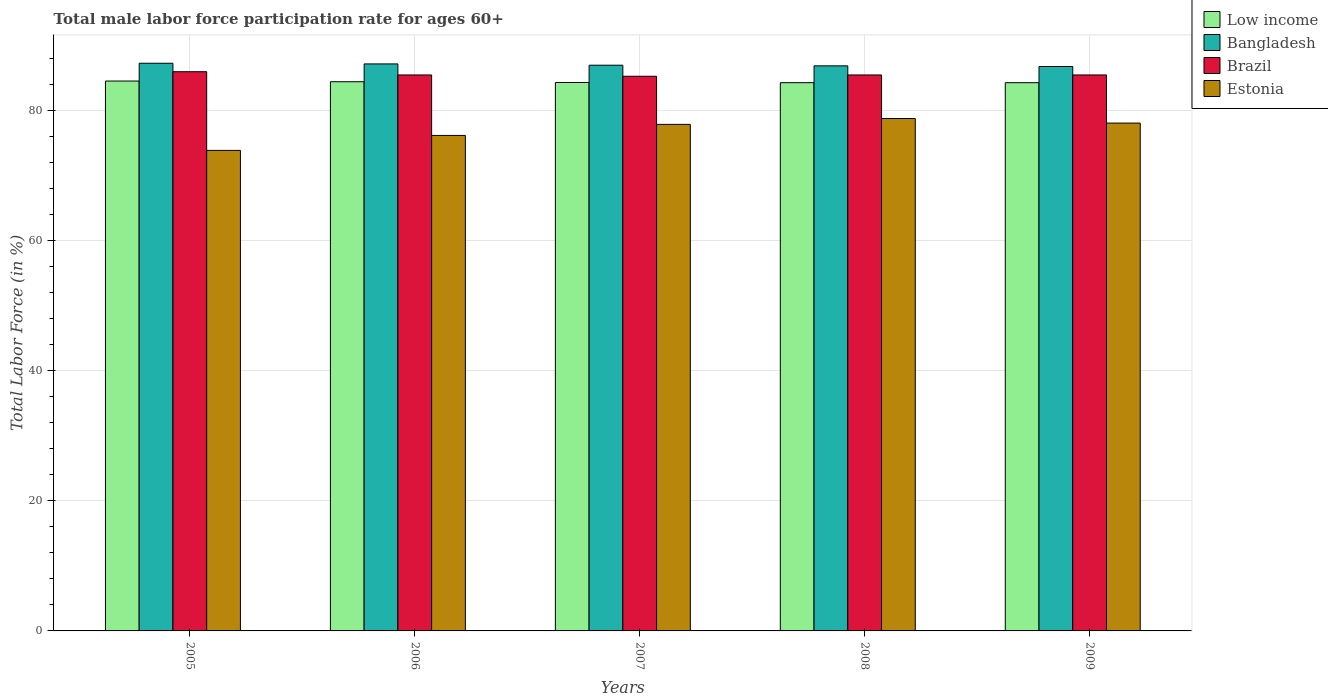How many different coloured bars are there?
Offer a terse response. 4. Are the number of bars per tick equal to the number of legend labels?
Your answer should be very brief. Yes. Are the number of bars on each tick of the X-axis equal?
Provide a short and direct response. Yes. How many bars are there on the 5th tick from the left?
Offer a terse response. 4. What is the label of the 1st group of bars from the left?
Your response must be concise. 2005. What is the male labor force participation rate in Low income in 2006?
Ensure brevity in your answer.  84.46. Across all years, what is the maximum male labor force participation rate in Brazil?
Make the answer very short. 86. Across all years, what is the minimum male labor force participation rate in Brazil?
Offer a terse response. 85.3. In which year was the male labor force participation rate in Estonia minimum?
Offer a terse response. 2005. What is the total male labor force participation rate in Brazil in the graph?
Your answer should be very brief. 427.8. What is the difference between the male labor force participation rate in Bangladesh in 2007 and that in 2009?
Make the answer very short. 0.2. What is the difference between the male labor force participation rate in Bangladesh in 2005 and the male labor force participation rate in Estonia in 2006?
Your answer should be compact. 11.1. What is the average male labor force participation rate in Brazil per year?
Offer a terse response. 85.56. In the year 2007, what is the difference between the male labor force participation rate in Brazil and male labor force participation rate in Estonia?
Your answer should be compact. 7.4. What is the ratio of the male labor force participation rate in Brazil in 2005 to that in 2007?
Offer a very short reply. 1.01. What is the difference between the highest and the second highest male labor force participation rate in Bangladesh?
Keep it short and to the point. 0.1. What is the difference between the highest and the lowest male labor force participation rate in Low income?
Keep it short and to the point. 0.25. Is the sum of the male labor force participation rate in Low income in 2005 and 2006 greater than the maximum male labor force participation rate in Bangladesh across all years?
Offer a terse response. Yes. Is it the case that in every year, the sum of the male labor force participation rate in Low income and male labor force participation rate in Estonia is greater than the sum of male labor force participation rate in Brazil and male labor force participation rate in Bangladesh?
Make the answer very short. Yes. What does the 1st bar from the right in 2009 represents?
Provide a short and direct response. Estonia. How many years are there in the graph?
Provide a succinct answer. 5. Does the graph contain grids?
Ensure brevity in your answer.  Yes. Where does the legend appear in the graph?
Provide a succinct answer. Top right. How many legend labels are there?
Your response must be concise. 4. What is the title of the graph?
Make the answer very short. Total male labor force participation rate for ages 60+. What is the Total Labor Force (in %) of Low income in 2005?
Offer a very short reply. 84.57. What is the Total Labor Force (in %) of Bangladesh in 2005?
Offer a very short reply. 87.3. What is the Total Labor Force (in %) in Brazil in 2005?
Your answer should be very brief. 86. What is the Total Labor Force (in %) of Estonia in 2005?
Keep it short and to the point. 73.9. What is the Total Labor Force (in %) of Low income in 2006?
Ensure brevity in your answer.  84.46. What is the Total Labor Force (in %) of Bangladesh in 2006?
Make the answer very short. 87.2. What is the Total Labor Force (in %) of Brazil in 2006?
Make the answer very short. 85.5. What is the Total Labor Force (in %) of Estonia in 2006?
Provide a succinct answer. 76.2. What is the Total Labor Force (in %) of Low income in 2007?
Provide a short and direct response. 84.34. What is the Total Labor Force (in %) of Bangladesh in 2007?
Keep it short and to the point. 87. What is the Total Labor Force (in %) of Brazil in 2007?
Ensure brevity in your answer.  85.3. What is the Total Labor Force (in %) of Estonia in 2007?
Provide a short and direct response. 77.9. What is the Total Labor Force (in %) in Low income in 2008?
Provide a short and direct response. 84.31. What is the Total Labor Force (in %) of Bangladesh in 2008?
Make the answer very short. 86.9. What is the Total Labor Force (in %) of Brazil in 2008?
Keep it short and to the point. 85.5. What is the Total Labor Force (in %) of Estonia in 2008?
Give a very brief answer. 78.8. What is the Total Labor Force (in %) in Low income in 2009?
Offer a terse response. 84.31. What is the Total Labor Force (in %) of Bangladesh in 2009?
Your answer should be very brief. 86.8. What is the Total Labor Force (in %) in Brazil in 2009?
Provide a short and direct response. 85.5. What is the Total Labor Force (in %) in Estonia in 2009?
Keep it short and to the point. 78.1. Across all years, what is the maximum Total Labor Force (in %) in Low income?
Ensure brevity in your answer.  84.57. Across all years, what is the maximum Total Labor Force (in %) of Bangladesh?
Ensure brevity in your answer.  87.3. Across all years, what is the maximum Total Labor Force (in %) in Estonia?
Offer a terse response. 78.8. Across all years, what is the minimum Total Labor Force (in %) in Low income?
Provide a succinct answer. 84.31. Across all years, what is the minimum Total Labor Force (in %) in Bangladesh?
Ensure brevity in your answer.  86.8. Across all years, what is the minimum Total Labor Force (in %) in Brazil?
Make the answer very short. 85.3. Across all years, what is the minimum Total Labor Force (in %) in Estonia?
Offer a very short reply. 73.9. What is the total Total Labor Force (in %) of Low income in the graph?
Your answer should be very brief. 421.99. What is the total Total Labor Force (in %) of Bangladesh in the graph?
Offer a very short reply. 435.2. What is the total Total Labor Force (in %) in Brazil in the graph?
Your response must be concise. 427.8. What is the total Total Labor Force (in %) in Estonia in the graph?
Keep it short and to the point. 384.9. What is the difference between the Total Labor Force (in %) of Low income in 2005 and that in 2006?
Your answer should be compact. 0.11. What is the difference between the Total Labor Force (in %) in Brazil in 2005 and that in 2006?
Offer a terse response. 0.5. What is the difference between the Total Labor Force (in %) of Low income in 2005 and that in 2007?
Ensure brevity in your answer.  0.22. What is the difference between the Total Labor Force (in %) in Bangladesh in 2005 and that in 2007?
Ensure brevity in your answer.  0.3. What is the difference between the Total Labor Force (in %) in Low income in 2005 and that in 2008?
Provide a succinct answer. 0.25. What is the difference between the Total Labor Force (in %) in Brazil in 2005 and that in 2008?
Offer a very short reply. 0.5. What is the difference between the Total Labor Force (in %) in Estonia in 2005 and that in 2008?
Provide a succinct answer. -4.9. What is the difference between the Total Labor Force (in %) of Low income in 2005 and that in 2009?
Offer a very short reply. 0.25. What is the difference between the Total Labor Force (in %) of Bangladesh in 2005 and that in 2009?
Make the answer very short. 0.5. What is the difference between the Total Labor Force (in %) in Estonia in 2005 and that in 2009?
Keep it short and to the point. -4.2. What is the difference between the Total Labor Force (in %) of Low income in 2006 and that in 2007?
Your response must be concise. 0.12. What is the difference between the Total Labor Force (in %) of Bangladesh in 2006 and that in 2007?
Keep it short and to the point. 0.2. What is the difference between the Total Labor Force (in %) of Low income in 2006 and that in 2008?
Keep it short and to the point. 0.15. What is the difference between the Total Labor Force (in %) of Estonia in 2006 and that in 2008?
Your response must be concise. -2.6. What is the difference between the Total Labor Force (in %) in Low income in 2006 and that in 2009?
Your answer should be very brief. 0.15. What is the difference between the Total Labor Force (in %) of Bangladesh in 2006 and that in 2009?
Ensure brevity in your answer.  0.4. What is the difference between the Total Labor Force (in %) of Brazil in 2006 and that in 2009?
Ensure brevity in your answer.  0. What is the difference between the Total Labor Force (in %) in Estonia in 2006 and that in 2009?
Keep it short and to the point. -1.9. What is the difference between the Total Labor Force (in %) in Low income in 2007 and that in 2008?
Your answer should be compact. 0.03. What is the difference between the Total Labor Force (in %) in Bangladesh in 2007 and that in 2008?
Keep it short and to the point. 0.1. What is the difference between the Total Labor Force (in %) in Estonia in 2007 and that in 2008?
Give a very brief answer. -0.9. What is the difference between the Total Labor Force (in %) in Low income in 2007 and that in 2009?
Your answer should be very brief. 0.03. What is the difference between the Total Labor Force (in %) in Bangladesh in 2007 and that in 2009?
Ensure brevity in your answer.  0.2. What is the difference between the Total Labor Force (in %) of Low income in 2008 and that in 2009?
Offer a terse response. 0. What is the difference between the Total Labor Force (in %) in Bangladesh in 2008 and that in 2009?
Your answer should be very brief. 0.1. What is the difference between the Total Labor Force (in %) of Brazil in 2008 and that in 2009?
Ensure brevity in your answer.  0. What is the difference between the Total Labor Force (in %) of Low income in 2005 and the Total Labor Force (in %) of Bangladesh in 2006?
Provide a succinct answer. -2.63. What is the difference between the Total Labor Force (in %) of Low income in 2005 and the Total Labor Force (in %) of Brazil in 2006?
Offer a terse response. -0.93. What is the difference between the Total Labor Force (in %) in Low income in 2005 and the Total Labor Force (in %) in Estonia in 2006?
Offer a terse response. 8.37. What is the difference between the Total Labor Force (in %) of Bangladesh in 2005 and the Total Labor Force (in %) of Brazil in 2006?
Provide a short and direct response. 1.8. What is the difference between the Total Labor Force (in %) of Bangladesh in 2005 and the Total Labor Force (in %) of Estonia in 2006?
Your answer should be compact. 11.1. What is the difference between the Total Labor Force (in %) in Brazil in 2005 and the Total Labor Force (in %) in Estonia in 2006?
Keep it short and to the point. 9.8. What is the difference between the Total Labor Force (in %) of Low income in 2005 and the Total Labor Force (in %) of Bangladesh in 2007?
Make the answer very short. -2.43. What is the difference between the Total Labor Force (in %) of Low income in 2005 and the Total Labor Force (in %) of Brazil in 2007?
Your answer should be very brief. -0.73. What is the difference between the Total Labor Force (in %) in Low income in 2005 and the Total Labor Force (in %) in Estonia in 2007?
Offer a terse response. 6.67. What is the difference between the Total Labor Force (in %) of Bangladesh in 2005 and the Total Labor Force (in %) of Estonia in 2007?
Offer a very short reply. 9.4. What is the difference between the Total Labor Force (in %) of Low income in 2005 and the Total Labor Force (in %) of Bangladesh in 2008?
Provide a succinct answer. -2.33. What is the difference between the Total Labor Force (in %) of Low income in 2005 and the Total Labor Force (in %) of Brazil in 2008?
Your response must be concise. -0.93. What is the difference between the Total Labor Force (in %) of Low income in 2005 and the Total Labor Force (in %) of Estonia in 2008?
Offer a terse response. 5.77. What is the difference between the Total Labor Force (in %) of Brazil in 2005 and the Total Labor Force (in %) of Estonia in 2008?
Your answer should be very brief. 7.2. What is the difference between the Total Labor Force (in %) of Low income in 2005 and the Total Labor Force (in %) of Bangladesh in 2009?
Your answer should be compact. -2.23. What is the difference between the Total Labor Force (in %) in Low income in 2005 and the Total Labor Force (in %) in Brazil in 2009?
Provide a succinct answer. -0.93. What is the difference between the Total Labor Force (in %) in Low income in 2005 and the Total Labor Force (in %) in Estonia in 2009?
Give a very brief answer. 6.47. What is the difference between the Total Labor Force (in %) in Bangladesh in 2005 and the Total Labor Force (in %) in Estonia in 2009?
Make the answer very short. 9.2. What is the difference between the Total Labor Force (in %) of Brazil in 2005 and the Total Labor Force (in %) of Estonia in 2009?
Offer a very short reply. 7.9. What is the difference between the Total Labor Force (in %) of Low income in 2006 and the Total Labor Force (in %) of Bangladesh in 2007?
Provide a short and direct response. -2.54. What is the difference between the Total Labor Force (in %) in Low income in 2006 and the Total Labor Force (in %) in Brazil in 2007?
Your response must be concise. -0.84. What is the difference between the Total Labor Force (in %) in Low income in 2006 and the Total Labor Force (in %) in Estonia in 2007?
Provide a short and direct response. 6.56. What is the difference between the Total Labor Force (in %) in Bangladesh in 2006 and the Total Labor Force (in %) in Brazil in 2007?
Provide a short and direct response. 1.9. What is the difference between the Total Labor Force (in %) of Bangladesh in 2006 and the Total Labor Force (in %) of Estonia in 2007?
Offer a very short reply. 9.3. What is the difference between the Total Labor Force (in %) of Low income in 2006 and the Total Labor Force (in %) of Bangladesh in 2008?
Provide a short and direct response. -2.44. What is the difference between the Total Labor Force (in %) in Low income in 2006 and the Total Labor Force (in %) in Brazil in 2008?
Provide a short and direct response. -1.04. What is the difference between the Total Labor Force (in %) in Low income in 2006 and the Total Labor Force (in %) in Estonia in 2008?
Your answer should be very brief. 5.66. What is the difference between the Total Labor Force (in %) in Bangladesh in 2006 and the Total Labor Force (in %) in Brazil in 2008?
Your response must be concise. 1.7. What is the difference between the Total Labor Force (in %) in Bangladesh in 2006 and the Total Labor Force (in %) in Estonia in 2008?
Ensure brevity in your answer.  8.4. What is the difference between the Total Labor Force (in %) in Low income in 2006 and the Total Labor Force (in %) in Bangladesh in 2009?
Offer a terse response. -2.34. What is the difference between the Total Labor Force (in %) in Low income in 2006 and the Total Labor Force (in %) in Brazil in 2009?
Make the answer very short. -1.04. What is the difference between the Total Labor Force (in %) of Low income in 2006 and the Total Labor Force (in %) of Estonia in 2009?
Provide a succinct answer. 6.36. What is the difference between the Total Labor Force (in %) in Bangladesh in 2006 and the Total Labor Force (in %) in Brazil in 2009?
Keep it short and to the point. 1.7. What is the difference between the Total Labor Force (in %) in Bangladesh in 2006 and the Total Labor Force (in %) in Estonia in 2009?
Keep it short and to the point. 9.1. What is the difference between the Total Labor Force (in %) in Low income in 2007 and the Total Labor Force (in %) in Bangladesh in 2008?
Your answer should be very brief. -2.56. What is the difference between the Total Labor Force (in %) of Low income in 2007 and the Total Labor Force (in %) of Brazil in 2008?
Give a very brief answer. -1.16. What is the difference between the Total Labor Force (in %) of Low income in 2007 and the Total Labor Force (in %) of Estonia in 2008?
Offer a very short reply. 5.54. What is the difference between the Total Labor Force (in %) in Bangladesh in 2007 and the Total Labor Force (in %) in Brazil in 2008?
Offer a very short reply. 1.5. What is the difference between the Total Labor Force (in %) in Bangladesh in 2007 and the Total Labor Force (in %) in Estonia in 2008?
Provide a short and direct response. 8.2. What is the difference between the Total Labor Force (in %) in Brazil in 2007 and the Total Labor Force (in %) in Estonia in 2008?
Give a very brief answer. 6.5. What is the difference between the Total Labor Force (in %) in Low income in 2007 and the Total Labor Force (in %) in Bangladesh in 2009?
Provide a short and direct response. -2.46. What is the difference between the Total Labor Force (in %) in Low income in 2007 and the Total Labor Force (in %) in Brazil in 2009?
Provide a succinct answer. -1.16. What is the difference between the Total Labor Force (in %) in Low income in 2007 and the Total Labor Force (in %) in Estonia in 2009?
Ensure brevity in your answer.  6.24. What is the difference between the Total Labor Force (in %) of Bangladesh in 2007 and the Total Labor Force (in %) of Brazil in 2009?
Your answer should be compact. 1.5. What is the difference between the Total Labor Force (in %) in Brazil in 2007 and the Total Labor Force (in %) in Estonia in 2009?
Provide a short and direct response. 7.2. What is the difference between the Total Labor Force (in %) in Low income in 2008 and the Total Labor Force (in %) in Bangladesh in 2009?
Your response must be concise. -2.49. What is the difference between the Total Labor Force (in %) in Low income in 2008 and the Total Labor Force (in %) in Brazil in 2009?
Your answer should be very brief. -1.19. What is the difference between the Total Labor Force (in %) of Low income in 2008 and the Total Labor Force (in %) of Estonia in 2009?
Offer a terse response. 6.21. What is the average Total Labor Force (in %) in Low income per year?
Offer a very short reply. 84.4. What is the average Total Labor Force (in %) of Bangladesh per year?
Give a very brief answer. 87.04. What is the average Total Labor Force (in %) of Brazil per year?
Offer a terse response. 85.56. What is the average Total Labor Force (in %) in Estonia per year?
Give a very brief answer. 76.98. In the year 2005, what is the difference between the Total Labor Force (in %) of Low income and Total Labor Force (in %) of Bangladesh?
Your answer should be compact. -2.73. In the year 2005, what is the difference between the Total Labor Force (in %) of Low income and Total Labor Force (in %) of Brazil?
Offer a terse response. -1.43. In the year 2005, what is the difference between the Total Labor Force (in %) in Low income and Total Labor Force (in %) in Estonia?
Make the answer very short. 10.67. In the year 2005, what is the difference between the Total Labor Force (in %) in Bangladesh and Total Labor Force (in %) in Brazil?
Make the answer very short. 1.3. In the year 2005, what is the difference between the Total Labor Force (in %) of Bangladesh and Total Labor Force (in %) of Estonia?
Offer a very short reply. 13.4. In the year 2005, what is the difference between the Total Labor Force (in %) in Brazil and Total Labor Force (in %) in Estonia?
Ensure brevity in your answer.  12.1. In the year 2006, what is the difference between the Total Labor Force (in %) in Low income and Total Labor Force (in %) in Bangladesh?
Keep it short and to the point. -2.74. In the year 2006, what is the difference between the Total Labor Force (in %) of Low income and Total Labor Force (in %) of Brazil?
Give a very brief answer. -1.04. In the year 2006, what is the difference between the Total Labor Force (in %) in Low income and Total Labor Force (in %) in Estonia?
Keep it short and to the point. 8.26. In the year 2007, what is the difference between the Total Labor Force (in %) of Low income and Total Labor Force (in %) of Bangladesh?
Ensure brevity in your answer.  -2.66. In the year 2007, what is the difference between the Total Labor Force (in %) of Low income and Total Labor Force (in %) of Brazil?
Provide a succinct answer. -0.96. In the year 2007, what is the difference between the Total Labor Force (in %) of Low income and Total Labor Force (in %) of Estonia?
Your response must be concise. 6.44. In the year 2008, what is the difference between the Total Labor Force (in %) of Low income and Total Labor Force (in %) of Bangladesh?
Keep it short and to the point. -2.59. In the year 2008, what is the difference between the Total Labor Force (in %) of Low income and Total Labor Force (in %) of Brazil?
Ensure brevity in your answer.  -1.19. In the year 2008, what is the difference between the Total Labor Force (in %) in Low income and Total Labor Force (in %) in Estonia?
Keep it short and to the point. 5.51. In the year 2008, what is the difference between the Total Labor Force (in %) of Bangladesh and Total Labor Force (in %) of Brazil?
Keep it short and to the point. 1.4. In the year 2008, what is the difference between the Total Labor Force (in %) of Bangladesh and Total Labor Force (in %) of Estonia?
Ensure brevity in your answer.  8.1. In the year 2008, what is the difference between the Total Labor Force (in %) in Brazil and Total Labor Force (in %) in Estonia?
Offer a terse response. 6.7. In the year 2009, what is the difference between the Total Labor Force (in %) in Low income and Total Labor Force (in %) in Bangladesh?
Offer a terse response. -2.49. In the year 2009, what is the difference between the Total Labor Force (in %) of Low income and Total Labor Force (in %) of Brazil?
Give a very brief answer. -1.19. In the year 2009, what is the difference between the Total Labor Force (in %) in Low income and Total Labor Force (in %) in Estonia?
Your answer should be compact. 6.21. In the year 2009, what is the difference between the Total Labor Force (in %) of Bangladesh and Total Labor Force (in %) of Brazil?
Make the answer very short. 1.3. What is the ratio of the Total Labor Force (in %) in Bangladesh in 2005 to that in 2006?
Offer a terse response. 1. What is the ratio of the Total Labor Force (in %) in Brazil in 2005 to that in 2006?
Keep it short and to the point. 1.01. What is the ratio of the Total Labor Force (in %) of Estonia in 2005 to that in 2006?
Provide a short and direct response. 0.97. What is the ratio of the Total Labor Force (in %) in Low income in 2005 to that in 2007?
Ensure brevity in your answer.  1. What is the ratio of the Total Labor Force (in %) of Brazil in 2005 to that in 2007?
Your answer should be compact. 1.01. What is the ratio of the Total Labor Force (in %) of Estonia in 2005 to that in 2007?
Give a very brief answer. 0.95. What is the ratio of the Total Labor Force (in %) in Bangladesh in 2005 to that in 2008?
Provide a succinct answer. 1. What is the ratio of the Total Labor Force (in %) of Brazil in 2005 to that in 2008?
Your answer should be very brief. 1.01. What is the ratio of the Total Labor Force (in %) in Estonia in 2005 to that in 2008?
Make the answer very short. 0.94. What is the ratio of the Total Labor Force (in %) of Bangladesh in 2005 to that in 2009?
Keep it short and to the point. 1.01. What is the ratio of the Total Labor Force (in %) of Brazil in 2005 to that in 2009?
Your answer should be very brief. 1.01. What is the ratio of the Total Labor Force (in %) in Estonia in 2005 to that in 2009?
Provide a succinct answer. 0.95. What is the ratio of the Total Labor Force (in %) in Low income in 2006 to that in 2007?
Offer a very short reply. 1. What is the ratio of the Total Labor Force (in %) in Bangladesh in 2006 to that in 2007?
Offer a terse response. 1. What is the ratio of the Total Labor Force (in %) of Brazil in 2006 to that in 2007?
Provide a succinct answer. 1. What is the ratio of the Total Labor Force (in %) of Estonia in 2006 to that in 2007?
Your answer should be very brief. 0.98. What is the ratio of the Total Labor Force (in %) of Brazil in 2006 to that in 2008?
Provide a short and direct response. 1. What is the ratio of the Total Labor Force (in %) in Estonia in 2006 to that in 2008?
Give a very brief answer. 0.97. What is the ratio of the Total Labor Force (in %) in Low income in 2006 to that in 2009?
Offer a terse response. 1. What is the ratio of the Total Labor Force (in %) of Estonia in 2006 to that in 2009?
Give a very brief answer. 0.98. What is the ratio of the Total Labor Force (in %) of Low income in 2007 to that in 2008?
Your answer should be compact. 1. What is the ratio of the Total Labor Force (in %) in Bangladesh in 2007 to that in 2008?
Make the answer very short. 1. What is the ratio of the Total Labor Force (in %) of Bangladesh in 2007 to that in 2009?
Give a very brief answer. 1. What is the ratio of the Total Labor Force (in %) in Estonia in 2007 to that in 2009?
Offer a terse response. 1. What is the ratio of the Total Labor Force (in %) of Low income in 2008 to that in 2009?
Ensure brevity in your answer.  1. What is the ratio of the Total Labor Force (in %) of Estonia in 2008 to that in 2009?
Your response must be concise. 1.01. What is the difference between the highest and the second highest Total Labor Force (in %) in Low income?
Provide a short and direct response. 0.11. What is the difference between the highest and the second highest Total Labor Force (in %) of Bangladesh?
Keep it short and to the point. 0.1. What is the difference between the highest and the second highest Total Labor Force (in %) of Brazil?
Make the answer very short. 0.5. What is the difference between the highest and the second highest Total Labor Force (in %) in Estonia?
Ensure brevity in your answer.  0.7. What is the difference between the highest and the lowest Total Labor Force (in %) of Low income?
Keep it short and to the point. 0.25. What is the difference between the highest and the lowest Total Labor Force (in %) of Bangladesh?
Your answer should be compact. 0.5. What is the difference between the highest and the lowest Total Labor Force (in %) of Brazil?
Your response must be concise. 0.7. What is the difference between the highest and the lowest Total Labor Force (in %) of Estonia?
Offer a very short reply. 4.9. 